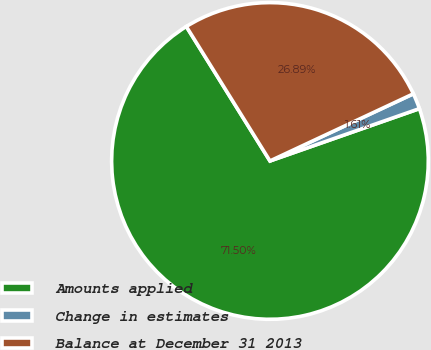Convert chart to OTSL. <chart><loc_0><loc_0><loc_500><loc_500><pie_chart><fcel>Amounts applied<fcel>Change in estimates<fcel>Balance at December 31 2013<nl><fcel>71.51%<fcel>1.61%<fcel>26.89%<nl></chart> 